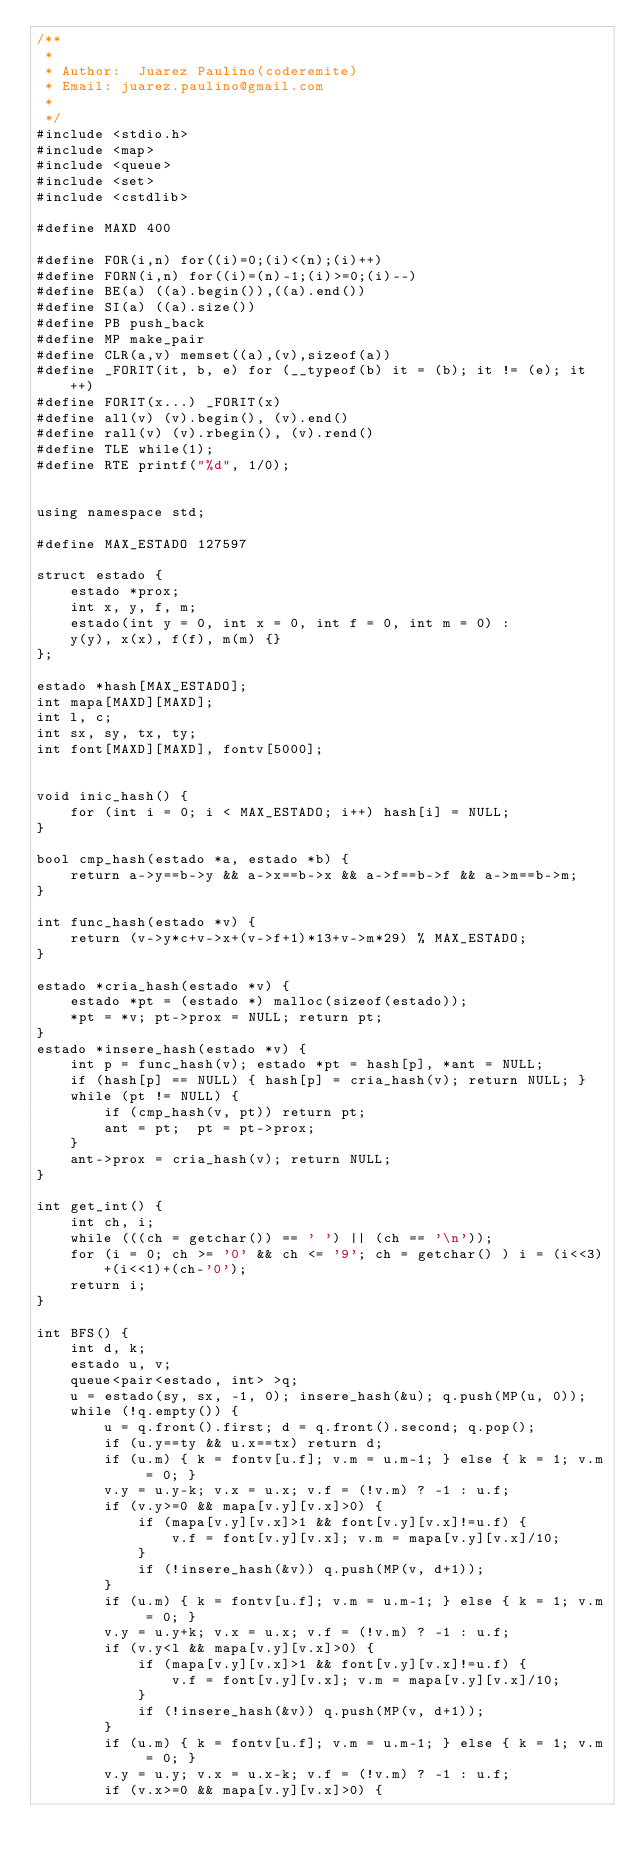<code> <loc_0><loc_0><loc_500><loc_500><_C++_>/**
 *
 * Author:  Juarez Paulino(coderemite)
 * Email: juarez.paulino@gmail.com
 *
 */
#include <stdio.h>
#include <map>
#include <queue>
#include <set>
#include <cstdlib>

#define MAXD 400

#define FOR(i,n) for((i)=0;(i)<(n);(i)++)
#define FORN(i,n) for((i)=(n)-1;(i)>=0;(i)--)
#define BE(a) ((a).begin()),((a).end())
#define SI(a) ((a).size())
#define PB push_back
#define MP make_pair
#define CLR(a,v) memset((a),(v),sizeof(a))
#define _FORIT(it, b, e) for (__typeof(b) it = (b); it != (e); it++)
#define FORIT(x...) _FORIT(x)
#define all(v) (v).begin(), (v).end()
#define rall(v) (v).rbegin(), (v).rend()
#define TLE while(1);
#define RTE printf("%d", 1/0);


using namespace std;

#define MAX_ESTADO 127597

struct estado {
    estado *prox;
    int x, y, f, m;
    estado(int y = 0, int x = 0, int f = 0, int m = 0) :
    y(y), x(x), f(f), m(m) {}
};

estado *hash[MAX_ESTADO];
int mapa[MAXD][MAXD];
int l, c;
int sx, sy, tx, ty;
int font[MAXD][MAXD], fontv[5000];


void inic_hash() {
    for (int i = 0; i < MAX_ESTADO; i++) hash[i] = NULL;
}

bool cmp_hash(estado *a, estado *b) {
    return a->y==b->y && a->x==b->x && a->f==b->f && a->m==b->m;
}

int func_hash(estado *v) {
    return (v->y*c+v->x+(v->f+1)*13+v->m*29) % MAX_ESTADO;
}

estado *cria_hash(estado *v) {
    estado *pt = (estado *) malloc(sizeof(estado));
    *pt = *v; pt->prox = NULL; return pt;
}
estado *insere_hash(estado *v) {
    int p = func_hash(v); estado *pt = hash[p], *ant = NULL;
    if (hash[p] == NULL) { hash[p] = cria_hash(v); return NULL; }
    while (pt != NULL) {
        if (cmp_hash(v, pt)) return pt;
        ant = pt;  pt = pt->prox;
    }
    ant->prox = cria_hash(v); return NULL;
}

int get_int() {
    int ch, i;
    while (((ch = getchar()) == ' ') || (ch == '\n'));
    for (i = 0; ch >= '0' && ch <= '9'; ch = getchar() ) i = (i<<3)+(i<<1)+(ch-'0');
    return i;
}

int BFS() {
    int d, k;
    estado u, v;
    queue<pair<estado, int> >q;
    u = estado(sy, sx, -1, 0); insere_hash(&u); q.push(MP(u, 0));
    while (!q.empty()) {
        u = q.front().first; d = q.front().second; q.pop();
        if (u.y==ty && u.x==tx) return d;
        if (u.m) { k = fontv[u.f]; v.m = u.m-1; } else { k = 1; v.m = 0; }
        v.y = u.y-k; v.x = u.x; v.f = (!v.m) ? -1 : u.f;
        if (v.y>=0 && mapa[v.y][v.x]>0) {
            if (mapa[v.y][v.x]>1 && font[v.y][v.x]!=u.f) {
                v.f = font[v.y][v.x]; v.m = mapa[v.y][v.x]/10;
            }
            if (!insere_hash(&v)) q.push(MP(v, d+1));
        }
        if (u.m) { k = fontv[u.f]; v.m = u.m-1; } else { k = 1; v.m = 0; }
        v.y = u.y+k; v.x = u.x; v.f = (!v.m) ? -1 : u.f;
        if (v.y<l && mapa[v.y][v.x]>0) {
            if (mapa[v.y][v.x]>1 && font[v.y][v.x]!=u.f) {
                v.f = font[v.y][v.x]; v.m = mapa[v.y][v.x]/10;
            }
            if (!insere_hash(&v)) q.push(MP(v, d+1));
        }
        if (u.m) { k = fontv[u.f]; v.m = u.m-1; } else { k = 1; v.m = 0; }
        v.y = u.y; v.x = u.x-k; v.f = (!v.m) ? -1 : u.f;
        if (v.x>=0 && mapa[v.y][v.x]>0) {</code> 